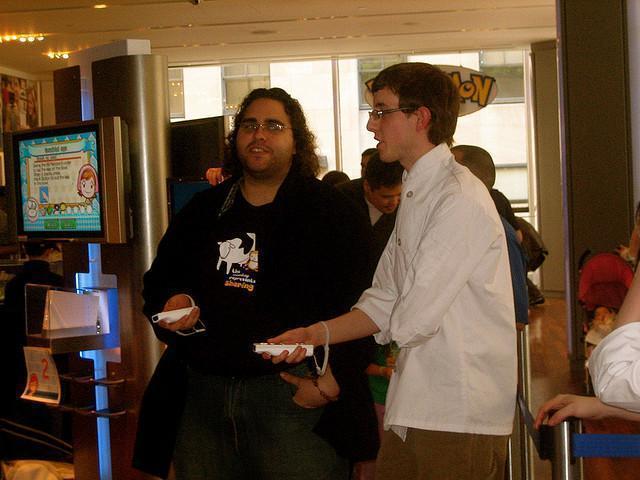What major gaming franchise is being advertised on the window?
Choose the correct response, then elucidate: 'Answer: answer
Rationale: rationale.'
Options: Pokemon, twin peaks, ghostbusters, mask. Answer: pokemon.
Rationale: There is a sign in the window that has the yellow, puffy font of this popular game. 